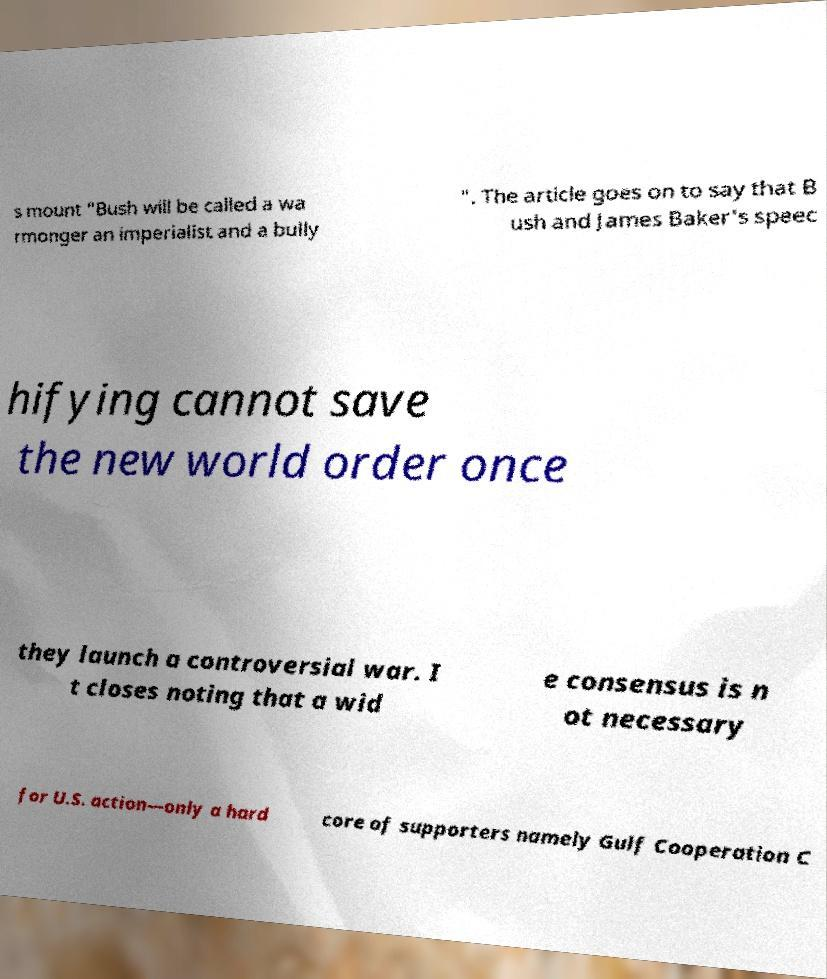Can you accurately transcribe the text from the provided image for me? s mount "Bush will be called a wa rmonger an imperialist and a bully ". The article goes on to say that B ush and James Baker's speec hifying cannot save the new world order once they launch a controversial war. I t closes noting that a wid e consensus is n ot necessary for U.S. action—only a hard core of supporters namely Gulf Cooperation C 